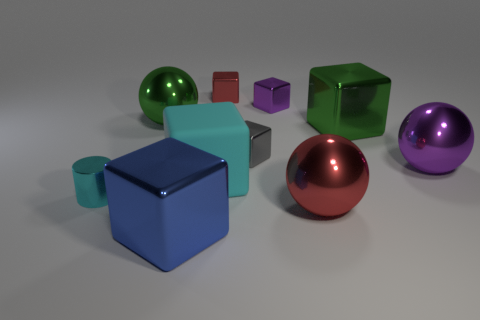What number of tiny things are in front of the tiny purple object and behind the purple ball?
Make the answer very short. 1. What number of metallic objects are either tiny brown blocks or cyan cubes?
Make the answer very short. 0. What size is the cyan object to the right of the big blue thing to the left of the tiny purple cube?
Your answer should be very brief. Large. What is the material of the other tiny object that is the same color as the rubber object?
Provide a succinct answer. Metal. Are there any blocks that are right of the red metallic thing behind the large metallic block that is on the right side of the big blue metal thing?
Make the answer very short. Yes. Do the red object to the left of the large red metal sphere and the block to the right of the red metallic ball have the same material?
Ensure brevity in your answer.  Yes. How many objects are either cubes or metallic objects that are in front of the tiny cyan cylinder?
Provide a succinct answer. 7. How many green objects are the same shape as the big red metallic thing?
Your response must be concise. 1. There is a gray thing that is the same size as the cyan metal cylinder; what is it made of?
Offer a terse response. Metal. What size is the red thing in front of the ball that is left of the sphere that is in front of the cyan shiny cylinder?
Give a very brief answer. Large. 